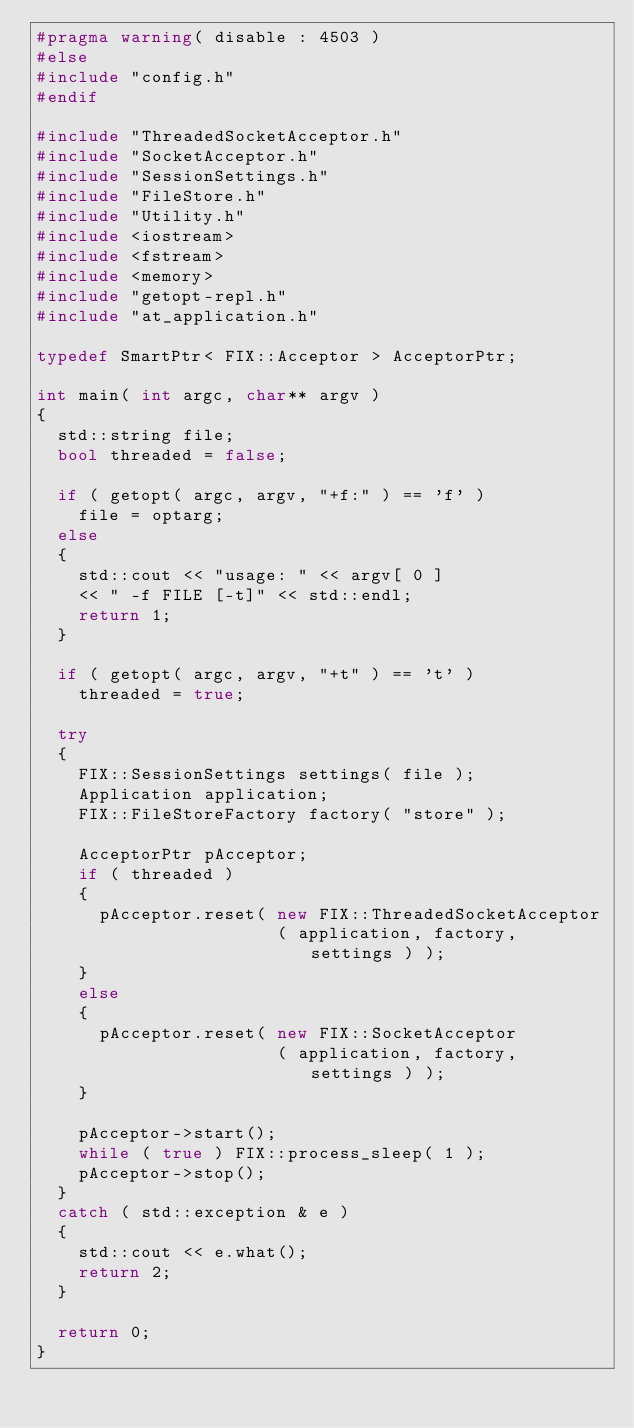Convert code to text. <code><loc_0><loc_0><loc_500><loc_500><_C++_>#pragma warning( disable : 4503 )
#else
#include "config.h"
#endif

#include "ThreadedSocketAcceptor.h"
#include "SocketAcceptor.h"
#include "SessionSettings.h"
#include "FileStore.h"
#include "Utility.h"
#include <iostream>
#include <fstream>
#include <memory>
#include "getopt-repl.h"
#include "at_application.h"

typedef SmartPtr< FIX::Acceptor > AcceptorPtr;

int main( int argc, char** argv )
{
  std::string file;
  bool threaded = false;

  if ( getopt( argc, argv, "+f:" ) == 'f' )
    file = optarg;
  else
  {
    std::cout << "usage: " << argv[ 0 ]
    << " -f FILE [-t]" << std::endl;
    return 1;
  }

  if ( getopt( argc, argv, "+t" ) == 't' )
    threaded = true;

  try
  {
    FIX::SessionSettings settings( file );
    Application application;
    FIX::FileStoreFactory factory( "store" );

    AcceptorPtr pAcceptor;
    if ( threaded )
    {
      pAcceptor.reset( new FIX::ThreadedSocketAcceptor
                       ( application, factory, settings ) );
    }
    else
    {
      pAcceptor.reset( new FIX::SocketAcceptor
                       ( application, factory, settings ) );
    }

    pAcceptor->start();
    while ( true ) FIX::process_sleep( 1 );
    pAcceptor->stop();
  }
  catch ( std::exception & e )
  {
    std::cout << e.what();
    return 2;
  }

  return 0;
}
</code> 